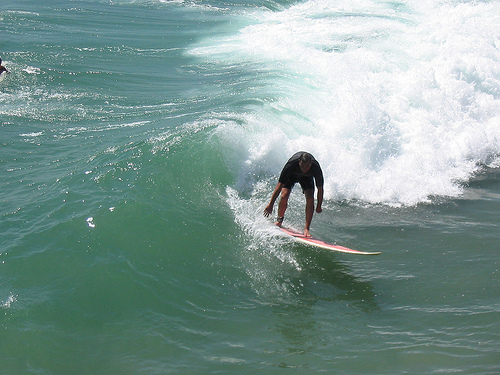Please provide a short description for this region: [0.6, 0.49, 0.63, 0.6]. This region shows the leg of a surfer, currently balancing on the surfboard and leaning forward in concentration. 